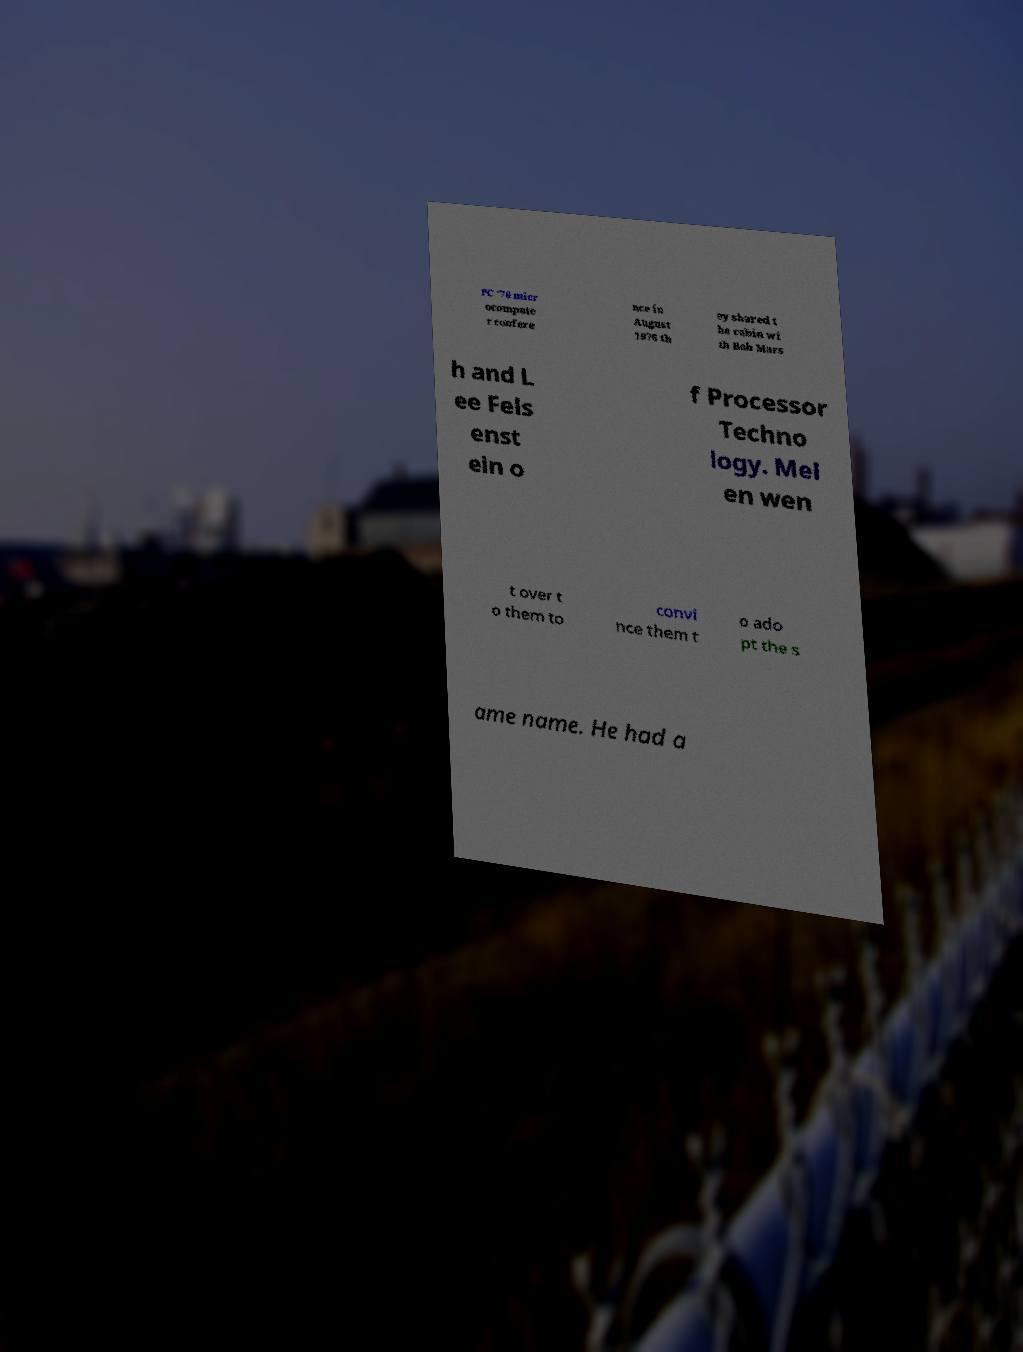Please identify and transcribe the text found in this image. PC '76 micr ocompute r confere nce in August 1976 th ey shared t he cabin wi th Bob Mars h and L ee Fels enst ein o f Processor Techno logy. Mel en wen t over t o them to convi nce them t o ado pt the s ame name. He had a 